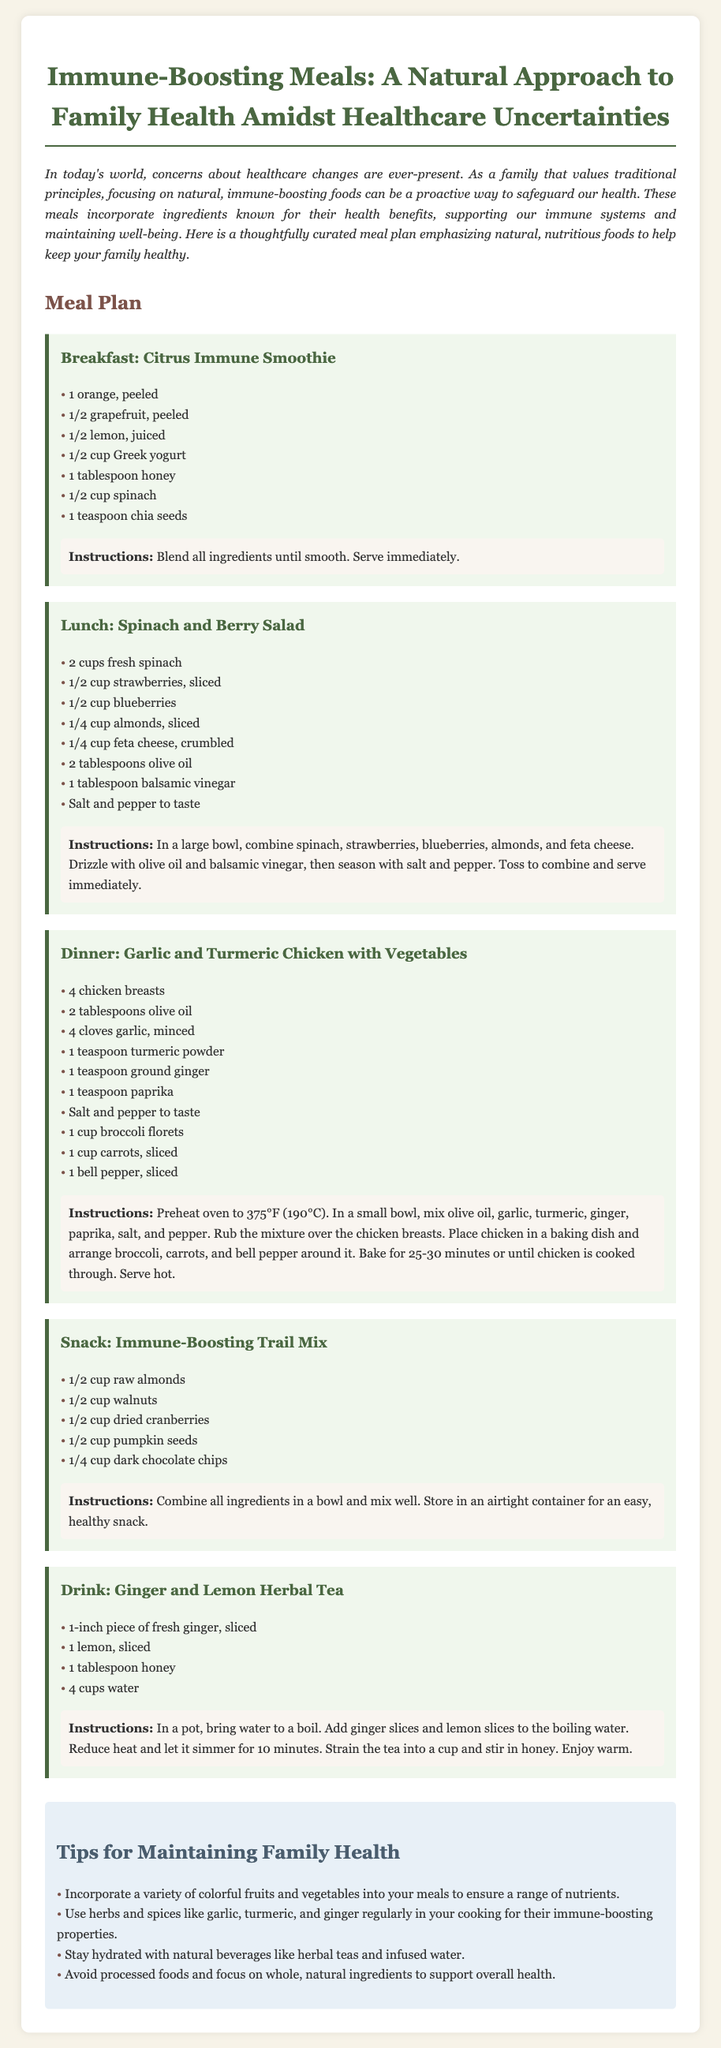What is the title of the meal plan? The title is given at the top of the meal plan document, providing a clear focus on the content.
Answer: Immune-Boosting Meals: A Natural Approach to Family Health Amidst Healthcare Uncertainties How many ingredients are there in the Citrus Immune Smoothie? The Citrus Immune Smoothie section lists all the necessary ingredients clearly.
Answer: 7 What type of salad is featured for lunch? The meal plan describes the lunch dish specifically in its heading.
Answer: Spinach and Berry Salad What is one of the tips for maintaining family health? The tips section provides several recommendations to support overall family health.
Answer: Incorporate a variety of colorful fruits and vegetables into your meals to ensure a range of nutrients Which vegetable is included in the Garlic and Turmeric Chicken dinner recipe? The dinner recipe lists various vegetables that accompany the chicken, indicating the dish's components.
Answer: Broccoli What is a main ingredient in the Drink section? The drink section includes specific ingredients that are essential to the recipe provided.
Answer: Ginger How long should the Ginger and Lemon Herbal Tea simmer? The preparation instructions detail the cooking time necessary for the tea.
Answer: 10 minutes What is the main protein source in the dinner recipe? The dinner recipe highlights the primary protein used in the preparation of the dish.
Answer: Chicken 